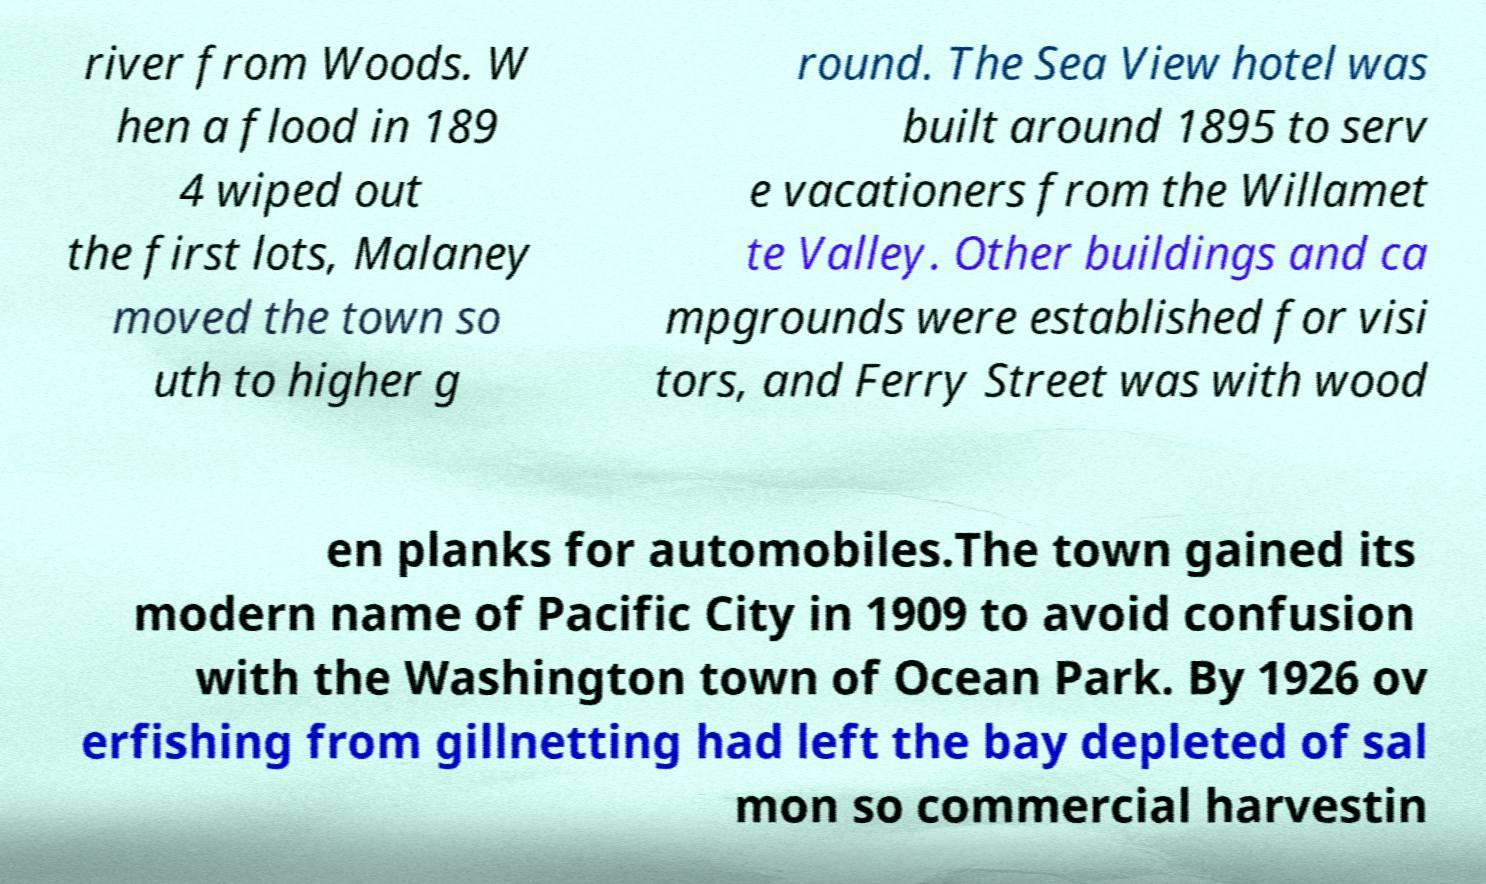Can you accurately transcribe the text from the provided image for me? river from Woods. W hen a flood in 189 4 wiped out the first lots, Malaney moved the town so uth to higher g round. The Sea View hotel was built around 1895 to serv e vacationers from the Willamet te Valley. Other buildings and ca mpgrounds were established for visi tors, and Ferry Street was with wood en planks for automobiles.The town gained its modern name of Pacific City in 1909 to avoid confusion with the Washington town of Ocean Park. By 1926 ov erfishing from gillnetting had left the bay depleted of sal mon so commercial harvestin 